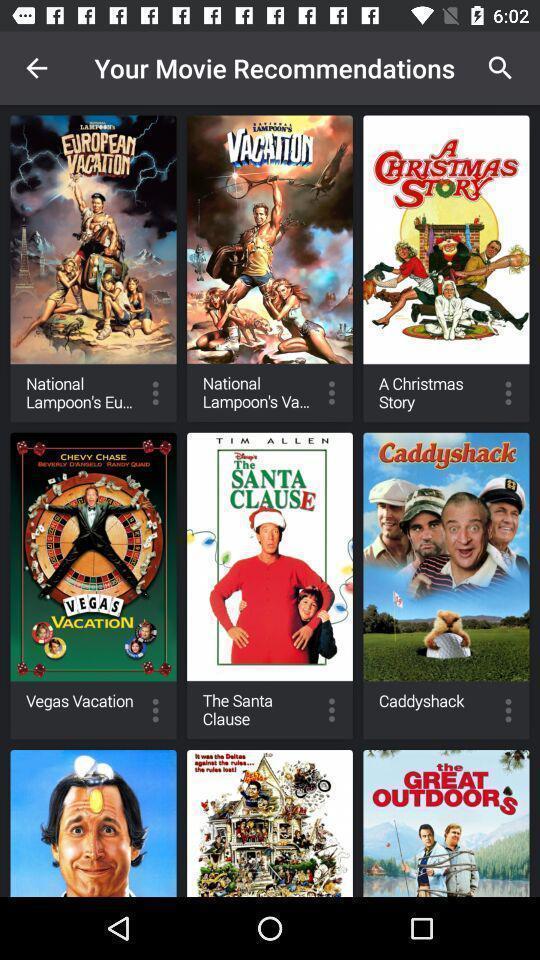Summarize the main components in this picture. Screen shows movie recommendations. 